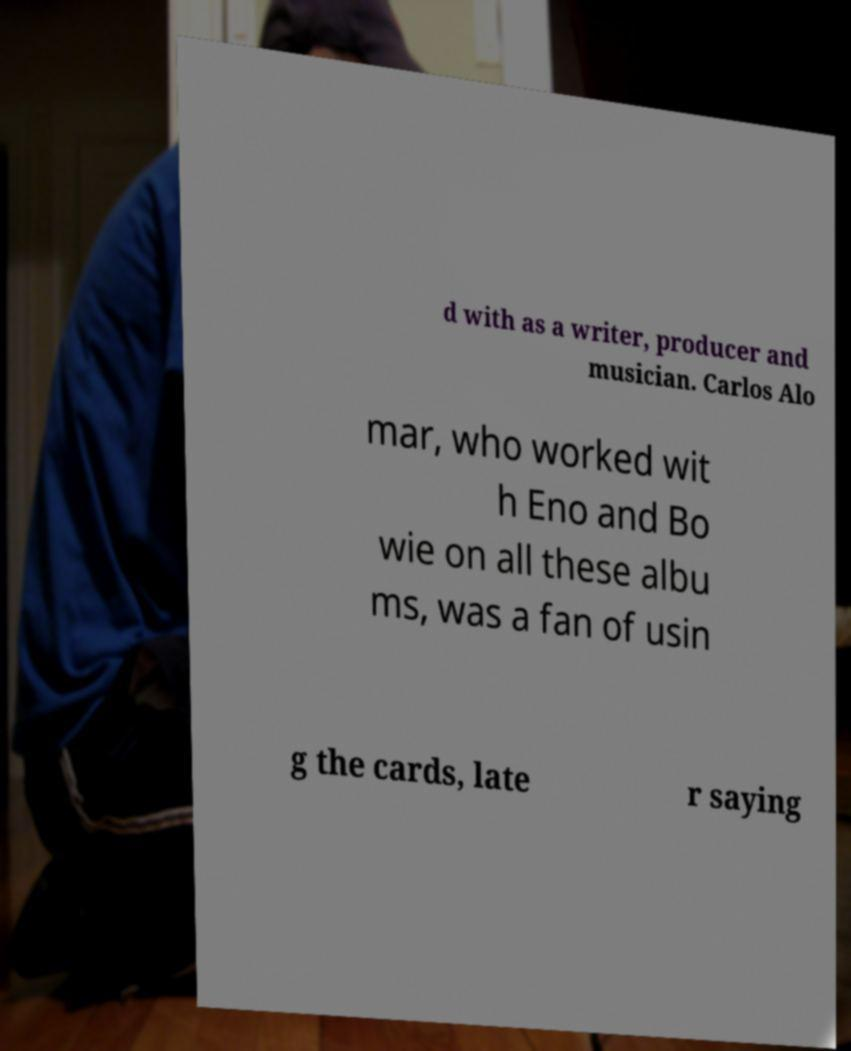What messages or text are displayed in this image? I need them in a readable, typed format. d with as a writer, producer and musician. Carlos Alo mar, who worked wit h Eno and Bo wie on all these albu ms, was a fan of usin g the cards, late r saying 